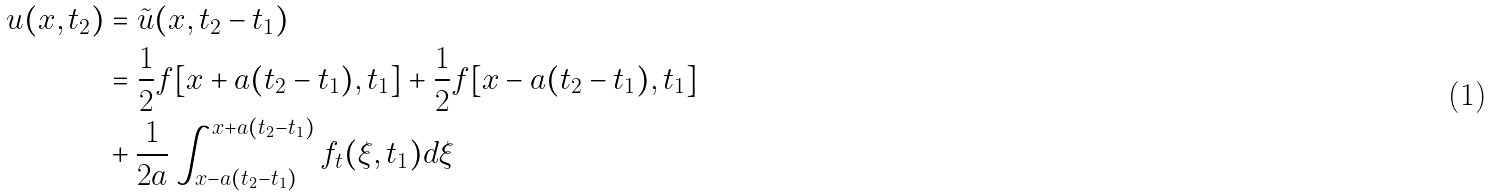Convert formula to latex. <formula><loc_0><loc_0><loc_500><loc_500>u ( x , t _ { 2 } ) & = \tilde { u } ( x , t _ { 2 } - t _ { 1 } ) \\ & = \frac { 1 } { 2 } f [ x + a ( t _ { 2 } - t _ { 1 } ) , t _ { 1 } ] + \frac { 1 } { 2 } f [ x - a ( t _ { 2 } - t _ { 1 } ) , t _ { 1 } ] \\ & + \frac { 1 } { 2 a } \int _ { x - a ( t _ { 2 } - t _ { 1 } ) } ^ { x + a ( t _ { 2 } - t _ { 1 } ) } { f _ { t } ( \xi , t _ { 1 } ) d \xi }</formula> 